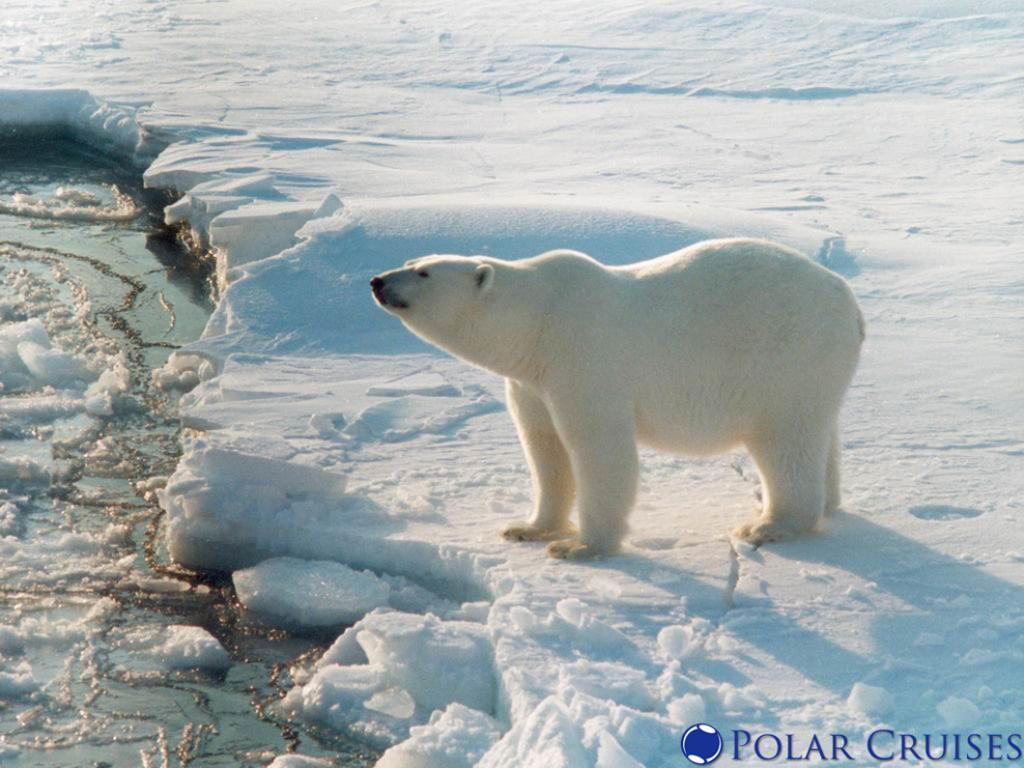What animal is the main subject of the image? There is a polar bear in the image. What type of environment is the polar bear in? The polar bear is on the snow. What else can be seen in the image besides the polar bear? There is water visible in the image. Is there any text or marking on the image itself? Yes, there is a watermark on the image. What type of story is the turkey telling in the image? There is no turkey present in the image, and therefore no storytelling can be observed. 